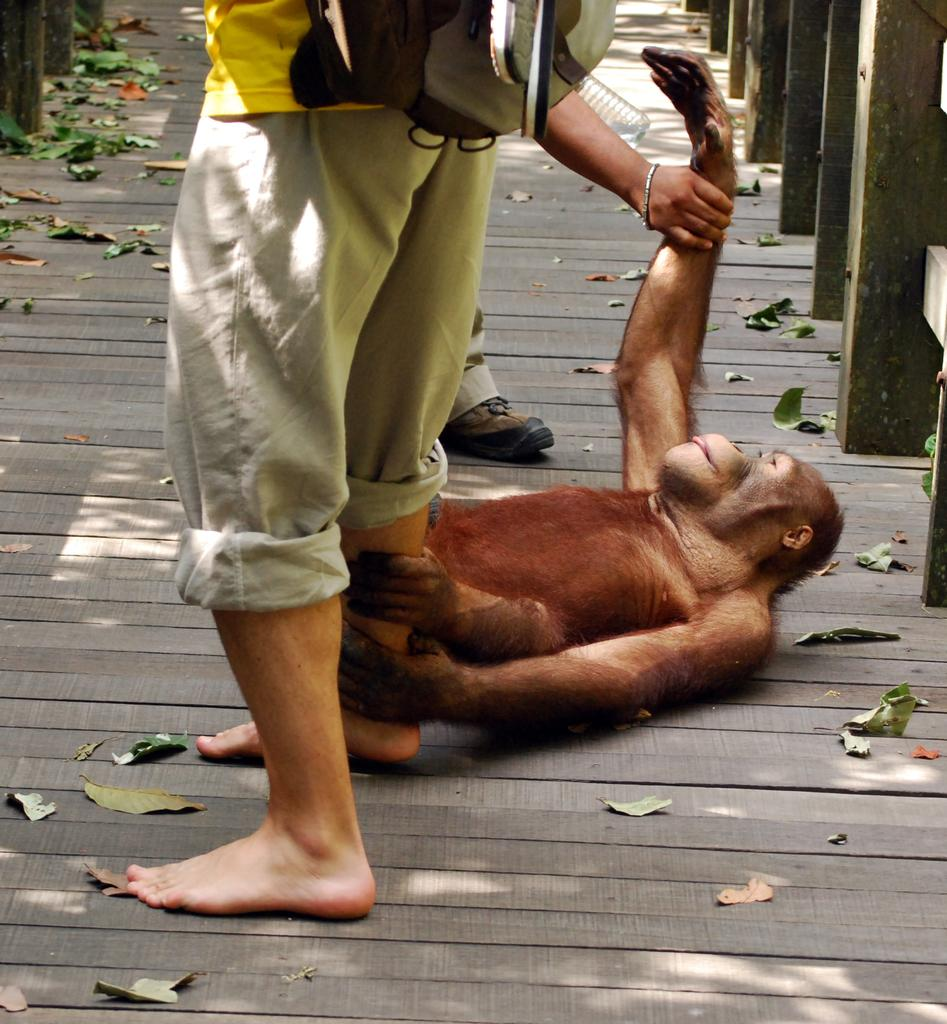How many people are in the image? There are two persons standing in the center of the image. What are the people doing in the image? The right side person is holding a monkey's hand. What can be seen in the background of the image? There are leaves and a bridge visible in the background of the image. What type of slope can be seen in the image? There is no slope present in the image. What impulse is causing the monkey to hold the person's hand? The image does not provide information about the reason for the monkey holding the person's hand, so we cannot determine the impulse. 